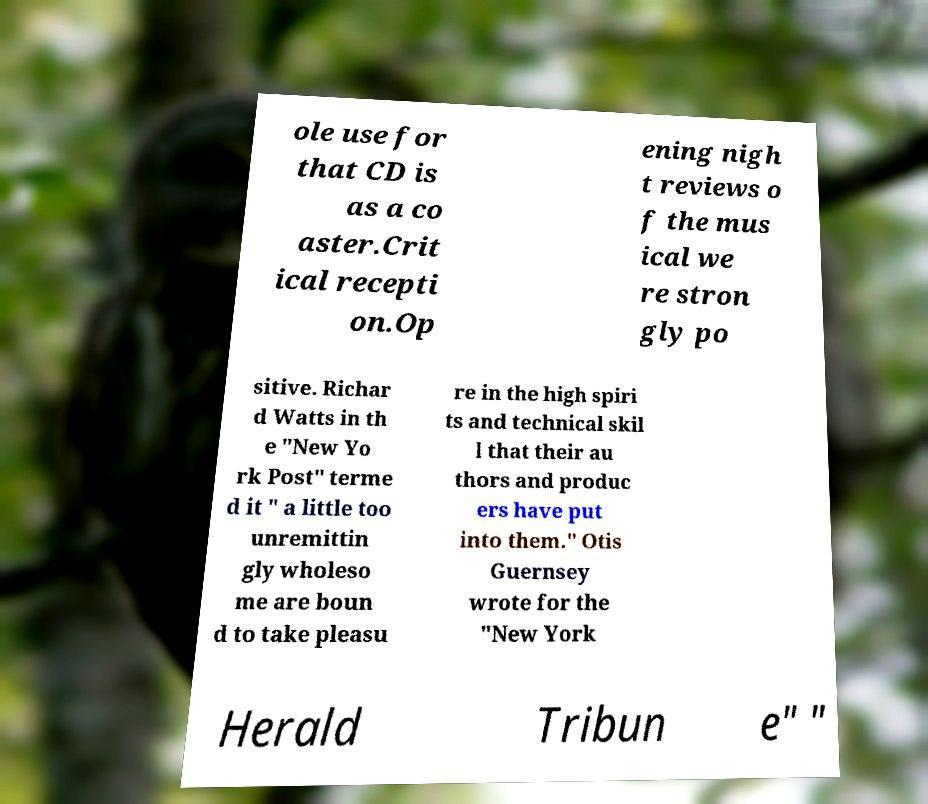Could you extract and type out the text from this image? ole use for that CD is as a co aster.Crit ical recepti on.Op ening nigh t reviews o f the mus ical we re stron gly po sitive. Richar d Watts in th e "New Yo rk Post" terme d it " a little too unremittin gly wholeso me are boun d to take pleasu re in the high spiri ts and technical skil l that their au thors and produc ers have put into them." Otis Guernsey wrote for the "New York Herald Tribun e" " 